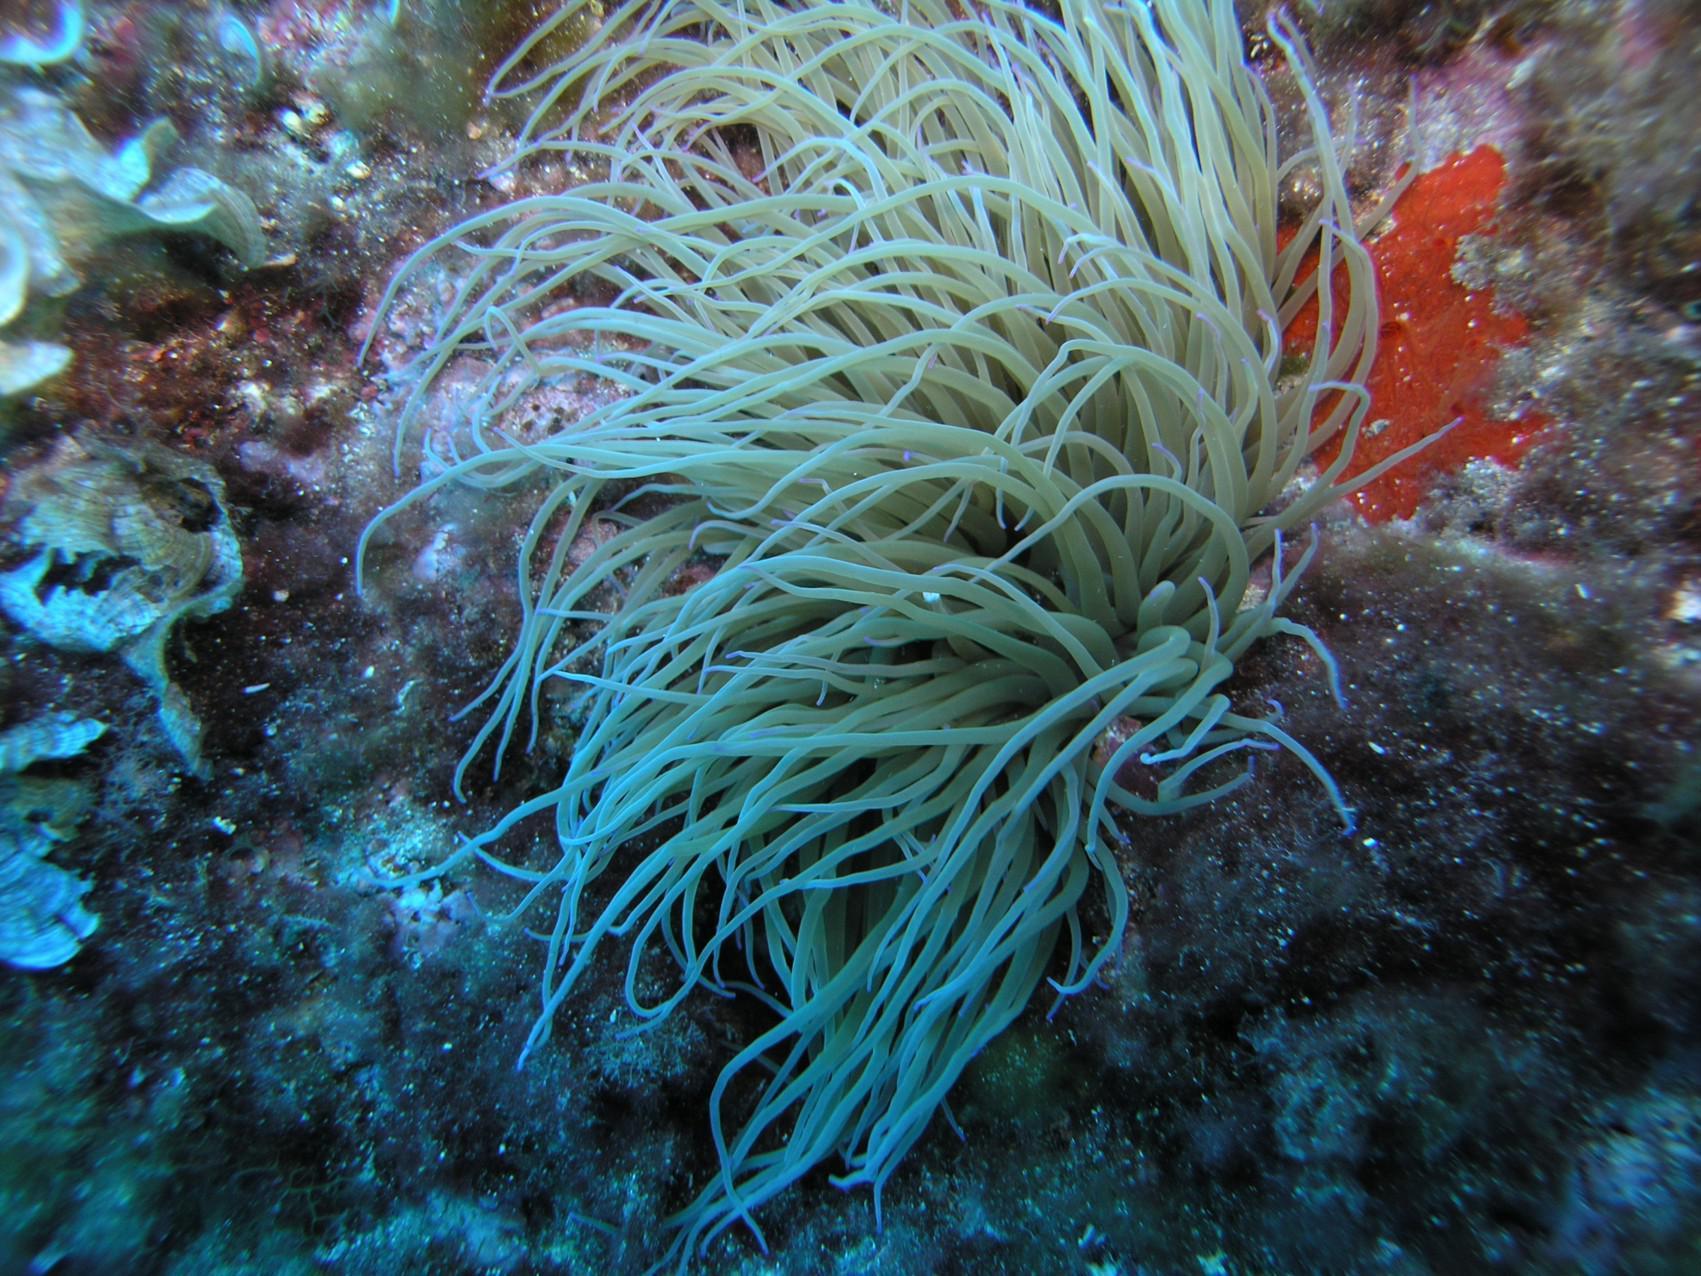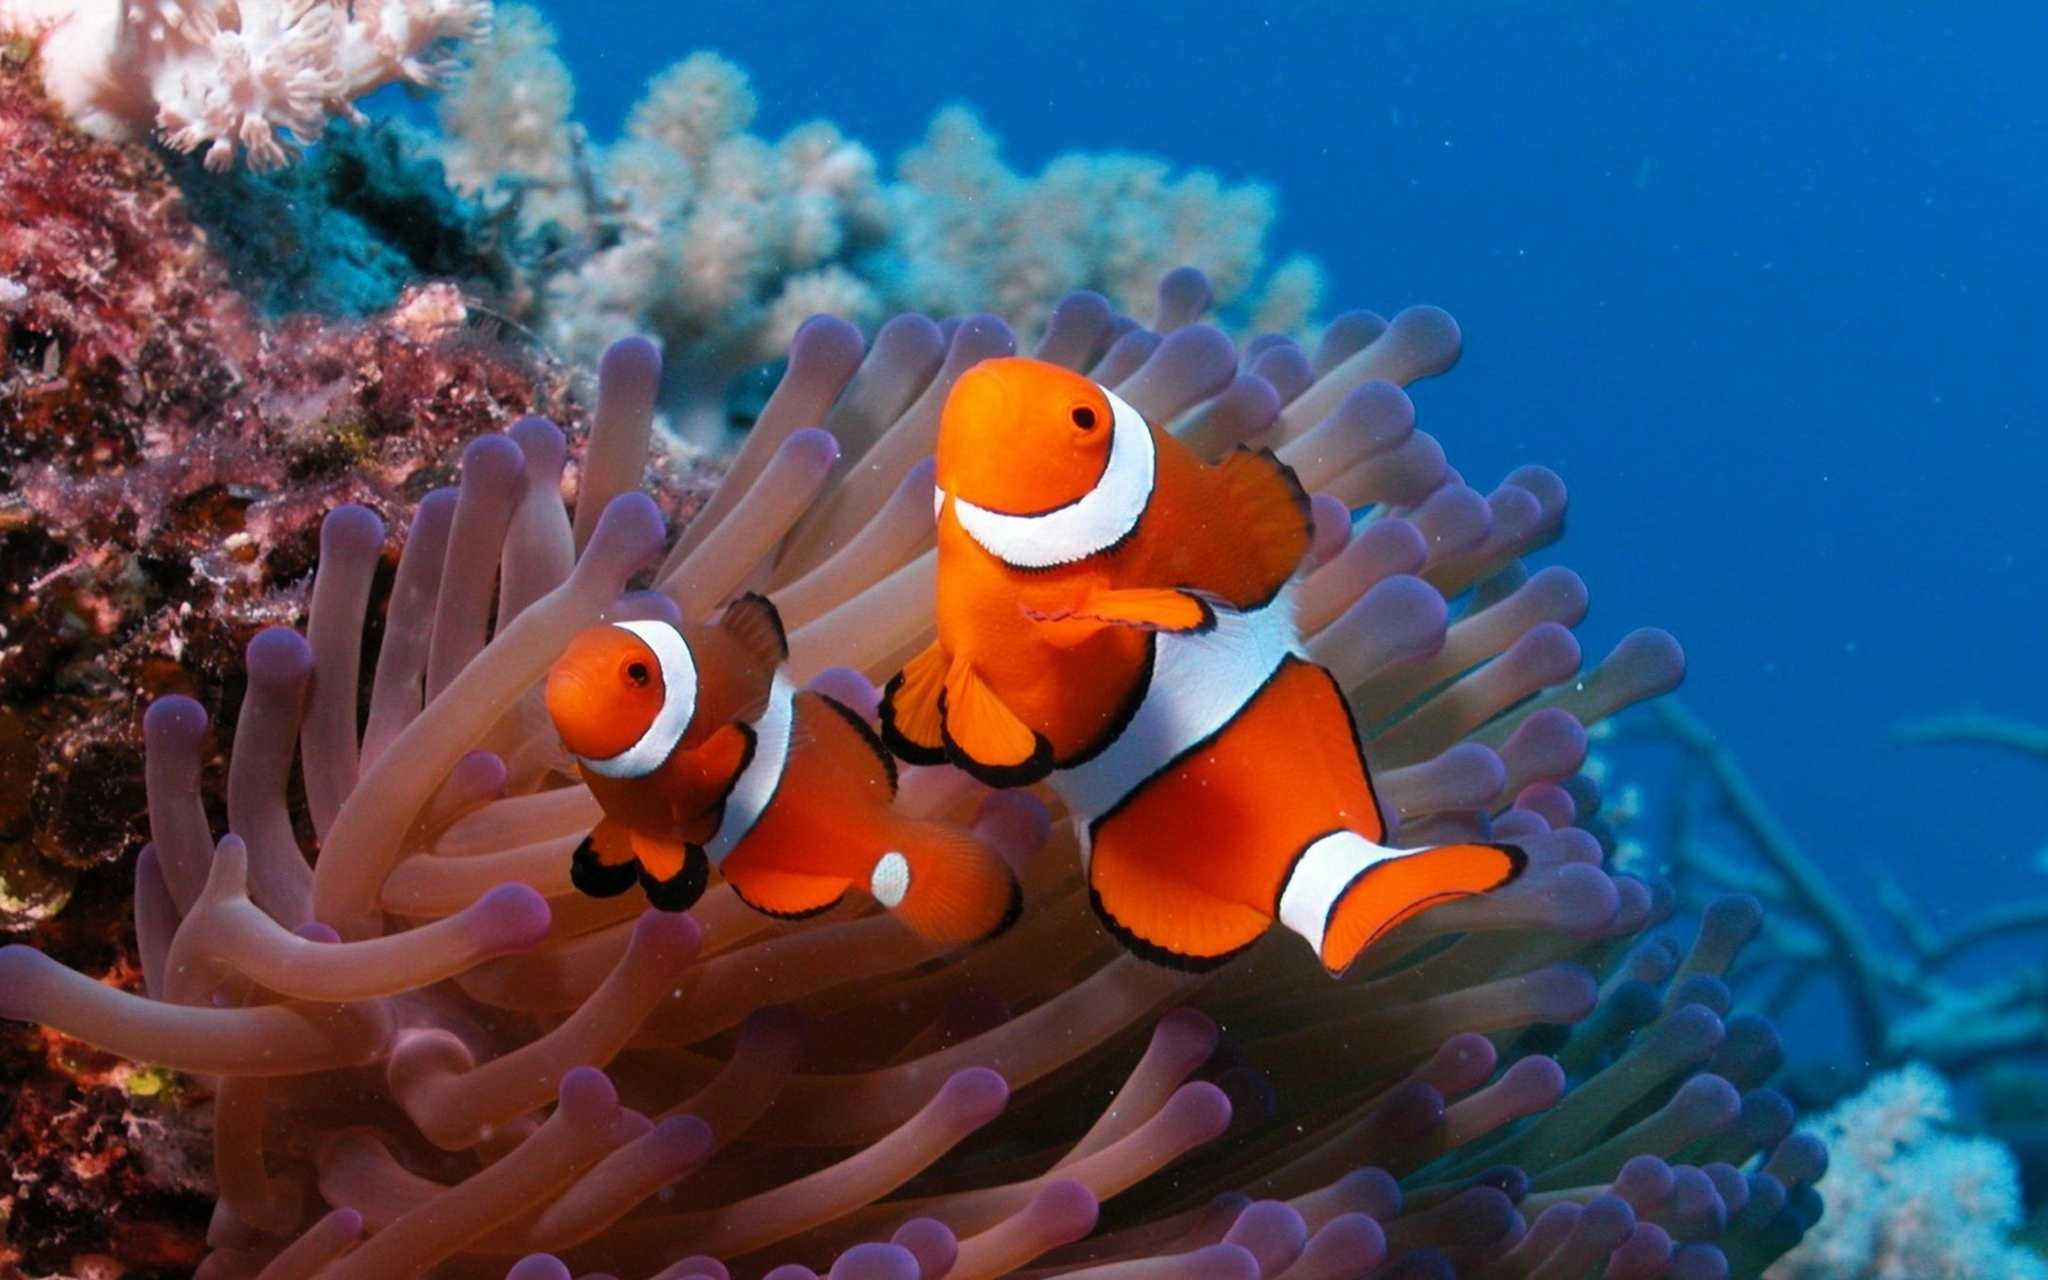The first image is the image on the left, the second image is the image on the right. Assess this claim about the two images: "There are at least two fishes in the pair of images.". Correct or not? Answer yes or no. Yes. The first image is the image on the left, the second image is the image on the right. Evaluate the accuracy of this statement regarding the images: "There are clown fish near the sea anemone.". Is it true? Answer yes or no. Yes. 